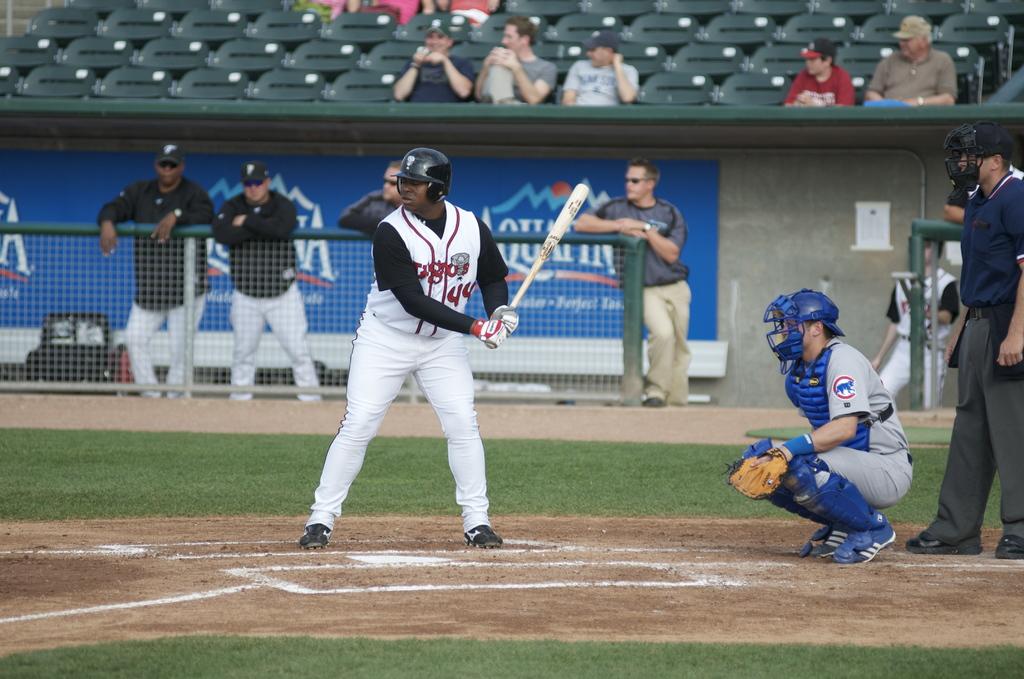What player number is at-bat?
Your answer should be very brief. 44. What brand of water is in the background?
Make the answer very short. Aquafina. 